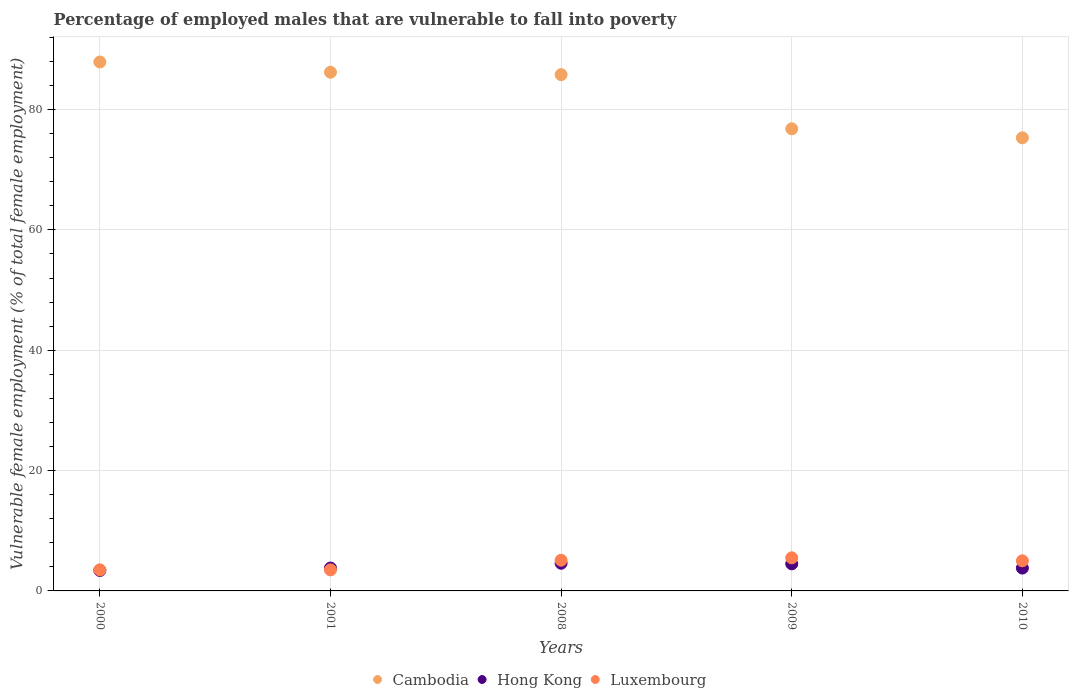How many different coloured dotlines are there?
Provide a short and direct response. 3. Across all years, what is the maximum percentage of employed males who are vulnerable to fall into poverty in Hong Kong?
Give a very brief answer. 4.6. Across all years, what is the minimum percentage of employed males who are vulnerable to fall into poverty in Hong Kong?
Your response must be concise. 3.4. What is the total percentage of employed males who are vulnerable to fall into poverty in Cambodia in the graph?
Your answer should be very brief. 412. What is the difference between the percentage of employed males who are vulnerable to fall into poverty in Luxembourg in 2008 and that in 2009?
Keep it short and to the point. -0.4. What is the difference between the percentage of employed males who are vulnerable to fall into poverty in Cambodia in 2009 and the percentage of employed males who are vulnerable to fall into poverty in Luxembourg in 2008?
Your answer should be very brief. 71.7. What is the average percentage of employed males who are vulnerable to fall into poverty in Hong Kong per year?
Provide a succinct answer. 4.02. In the year 2000, what is the difference between the percentage of employed males who are vulnerable to fall into poverty in Luxembourg and percentage of employed males who are vulnerable to fall into poverty in Cambodia?
Provide a succinct answer. -84.4. In how many years, is the percentage of employed males who are vulnerable to fall into poverty in Hong Kong greater than 12 %?
Ensure brevity in your answer.  0. What is the ratio of the percentage of employed males who are vulnerable to fall into poverty in Luxembourg in 2001 to that in 2010?
Ensure brevity in your answer.  0.7. Is the difference between the percentage of employed males who are vulnerable to fall into poverty in Luxembourg in 2000 and 2001 greater than the difference between the percentage of employed males who are vulnerable to fall into poverty in Cambodia in 2000 and 2001?
Ensure brevity in your answer.  No. What is the difference between the highest and the second highest percentage of employed males who are vulnerable to fall into poverty in Luxembourg?
Keep it short and to the point. 0.4. What is the difference between the highest and the lowest percentage of employed males who are vulnerable to fall into poverty in Cambodia?
Your answer should be very brief. 12.6. In how many years, is the percentage of employed males who are vulnerable to fall into poverty in Cambodia greater than the average percentage of employed males who are vulnerable to fall into poverty in Cambodia taken over all years?
Ensure brevity in your answer.  3. Is the percentage of employed males who are vulnerable to fall into poverty in Luxembourg strictly less than the percentage of employed males who are vulnerable to fall into poverty in Cambodia over the years?
Provide a succinct answer. Yes. How many dotlines are there?
Give a very brief answer. 3. Does the graph contain grids?
Provide a short and direct response. Yes. Where does the legend appear in the graph?
Offer a very short reply. Bottom center. What is the title of the graph?
Offer a very short reply. Percentage of employed males that are vulnerable to fall into poverty. Does "Micronesia" appear as one of the legend labels in the graph?
Make the answer very short. No. What is the label or title of the X-axis?
Your answer should be very brief. Years. What is the label or title of the Y-axis?
Provide a short and direct response. Vulnerable female employment (% of total female employment). What is the Vulnerable female employment (% of total female employment) in Cambodia in 2000?
Give a very brief answer. 87.9. What is the Vulnerable female employment (% of total female employment) in Hong Kong in 2000?
Your answer should be very brief. 3.4. What is the Vulnerable female employment (% of total female employment) of Cambodia in 2001?
Offer a very short reply. 86.2. What is the Vulnerable female employment (% of total female employment) of Hong Kong in 2001?
Offer a terse response. 3.8. What is the Vulnerable female employment (% of total female employment) in Luxembourg in 2001?
Make the answer very short. 3.5. What is the Vulnerable female employment (% of total female employment) in Cambodia in 2008?
Make the answer very short. 85.8. What is the Vulnerable female employment (% of total female employment) in Hong Kong in 2008?
Your answer should be compact. 4.6. What is the Vulnerable female employment (% of total female employment) in Luxembourg in 2008?
Provide a short and direct response. 5.1. What is the Vulnerable female employment (% of total female employment) of Cambodia in 2009?
Your answer should be very brief. 76.8. What is the Vulnerable female employment (% of total female employment) in Cambodia in 2010?
Offer a very short reply. 75.3. What is the Vulnerable female employment (% of total female employment) of Hong Kong in 2010?
Keep it short and to the point. 3.8. Across all years, what is the maximum Vulnerable female employment (% of total female employment) of Cambodia?
Your answer should be compact. 87.9. Across all years, what is the maximum Vulnerable female employment (% of total female employment) in Hong Kong?
Give a very brief answer. 4.6. Across all years, what is the maximum Vulnerable female employment (% of total female employment) of Luxembourg?
Your response must be concise. 5.5. Across all years, what is the minimum Vulnerable female employment (% of total female employment) in Cambodia?
Offer a terse response. 75.3. Across all years, what is the minimum Vulnerable female employment (% of total female employment) of Hong Kong?
Make the answer very short. 3.4. Across all years, what is the minimum Vulnerable female employment (% of total female employment) of Luxembourg?
Your answer should be very brief. 3.5. What is the total Vulnerable female employment (% of total female employment) in Cambodia in the graph?
Give a very brief answer. 412. What is the total Vulnerable female employment (% of total female employment) of Hong Kong in the graph?
Ensure brevity in your answer.  20.1. What is the total Vulnerable female employment (% of total female employment) in Luxembourg in the graph?
Offer a terse response. 22.6. What is the difference between the Vulnerable female employment (% of total female employment) in Luxembourg in 2000 and that in 2001?
Keep it short and to the point. 0. What is the difference between the Vulnerable female employment (% of total female employment) in Luxembourg in 2000 and that in 2008?
Your answer should be very brief. -1.6. What is the difference between the Vulnerable female employment (% of total female employment) of Hong Kong in 2000 and that in 2009?
Provide a short and direct response. -1.1. What is the difference between the Vulnerable female employment (% of total female employment) of Luxembourg in 2000 and that in 2010?
Make the answer very short. -1.5. What is the difference between the Vulnerable female employment (% of total female employment) of Hong Kong in 2001 and that in 2008?
Provide a short and direct response. -0.8. What is the difference between the Vulnerable female employment (% of total female employment) of Luxembourg in 2001 and that in 2008?
Ensure brevity in your answer.  -1.6. What is the difference between the Vulnerable female employment (% of total female employment) of Cambodia in 2001 and that in 2009?
Ensure brevity in your answer.  9.4. What is the difference between the Vulnerable female employment (% of total female employment) in Hong Kong in 2001 and that in 2009?
Your answer should be compact. -0.7. What is the difference between the Vulnerable female employment (% of total female employment) in Luxembourg in 2001 and that in 2009?
Keep it short and to the point. -2. What is the difference between the Vulnerable female employment (% of total female employment) in Hong Kong in 2001 and that in 2010?
Offer a terse response. 0. What is the difference between the Vulnerable female employment (% of total female employment) of Cambodia in 2008 and that in 2009?
Your answer should be compact. 9. What is the difference between the Vulnerable female employment (% of total female employment) of Luxembourg in 2008 and that in 2009?
Keep it short and to the point. -0.4. What is the difference between the Vulnerable female employment (% of total female employment) of Hong Kong in 2008 and that in 2010?
Offer a very short reply. 0.8. What is the difference between the Vulnerable female employment (% of total female employment) in Luxembourg in 2008 and that in 2010?
Your response must be concise. 0.1. What is the difference between the Vulnerable female employment (% of total female employment) of Cambodia in 2009 and that in 2010?
Your answer should be very brief. 1.5. What is the difference between the Vulnerable female employment (% of total female employment) in Hong Kong in 2009 and that in 2010?
Your response must be concise. 0.7. What is the difference between the Vulnerable female employment (% of total female employment) of Luxembourg in 2009 and that in 2010?
Provide a short and direct response. 0.5. What is the difference between the Vulnerable female employment (% of total female employment) in Cambodia in 2000 and the Vulnerable female employment (% of total female employment) in Hong Kong in 2001?
Provide a succinct answer. 84.1. What is the difference between the Vulnerable female employment (% of total female employment) in Cambodia in 2000 and the Vulnerable female employment (% of total female employment) in Luxembourg in 2001?
Give a very brief answer. 84.4. What is the difference between the Vulnerable female employment (% of total female employment) in Hong Kong in 2000 and the Vulnerable female employment (% of total female employment) in Luxembourg in 2001?
Your response must be concise. -0.1. What is the difference between the Vulnerable female employment (% of total female employment) of Cambodia in 2000 and the Vulnerable female employment (% of total female employment) of Hong Kong in 2008?
Make the answer very short. 83.3. What is the difference between the Vulnerable female employment (% of total female employment) in Cambodia in 2000 and the Vulnerable female employment (% of total female employment) in Luxembourg in 2008?
Your response must be concise. 82.8. What is the difference between the Vulnerable female employment (% of total female employment) in Hong Kong in 2000 and the Vulnerable female employment (% of total female employment) in Luxembourg in 2008?
Ensure brevity in your answer.  -1.7. What is the difference between the Vulnerable female employment (% of total female employment) of Cambodia in 2000 and the Vulnerable female employment (% of total female employment) of Hong Kong in 2009?
Provide a short and direct response. 83.4. What is the difference between the Vulnerable female employment (% of total female employment) of Cambodia in 2000 and the Vulnerable female employment (% of total female employment) of Luxembourg in 2009?
Offer a very short reply. 82.4. What is the difference between the Vulnerable female employment (% of total female employment) in Cambodia in 2000 and the Vulnerable female employment (% of total female employment) in Hong Kong in 2010?
Offer a terse response. 84.1. What is the difference between the Vulnerable female employment (% of total female employment) of Cambodia in 2000 and the Vulnerable female employment (% of total female employment) of Luxembourg in 2010?
Offer a terse response. 82.9. What is the difference between the Vulnerable female employment (% of total female employment) of Hong Kong in 2000 and the Vulnerable female employment (% of total female employment) of Luxembourg in 2010?
Your answer should be compact. -1.6. What is the difference between the Vulnerable female employment (% of total female employment) of Cambodia in 2001 and the Vulnerable female employment (% of total female employment) of Hong Kong in 2008?
Ensure brevity in your answer.  81.6. What is the difference between the Vulnerable female employment (% of total female employment) in Cambodia in 2001 and the Vulnerable female employment (% of total female employment) in Luxembourg in 2008?
Offer a terse response. 81.1. What is the difference between the Vulnerable female employment (% of total female employment) in Hong Kong in 2001 and the Vulnerable female employment (% of total female employment) in Luxembourg in 2008?
Offer a very short reply. -1.3. What is the difference between the Vulnerable female employment (% of total female employment) in Cambodia in 2001 and the Vulnerable female employment (% of total female employment) in Hong Kong in 2009?
Your answer should be compact. 81.7. What is the difference between the Vulnerable female employment (% of total female employment) of Cambodia in 2001 and the Vulnerable female employment (% of total female employment) of Luxembourg in 2009?
Your response must be concise. 80.7. What is the difference between the Vulnerable female employment (% of total female employment) in Hong Kong in 2001 and the Vulnerable female employment (% of total female employment) in Luxembourg in 2009?
Offer a very short reply. -1.7. What is the difference between the Vulnerable female employment (% of total female employment) of Cambodia in 2001 and the Vulnerable female employment (% of total female employment) of Hong Kong in 2010?
Keep it short and to the point. 82.4. What is the difference between the Vulnerable female employment (% of total female employment) of Cambodia in 2001 and the Vulnerable female employment (% of total female employment) of Luxembourg in 2010?
Provide a succinct answer. 81.2. What is the difference between the Vulnerable female employment (% of total female employment) in Hong Kong in 2001 and the Vulnerable female employment (% of total female employment) in Luxembourg in 2010?
Provide a succinct answer. -1.2. What is the difference between the Vulnerable female employment (% of total female employment) in Cambodia in 2008 and the Vulnerable female employment (% of total female employment) in Hong Kong in 2009?
Offer a very short reply. 81.3. What is the difference between the Vulnerable female employment (% of total female employment) in Cambodia in 2008 and the Vulnerable female employment (% of total female employment) in Luxembourg in 2009?
Ensure brevity in your answer.  80.3. What is the difference between the Vulnerable female employment (% of total female employment) in Hong Kong in 2008 and the Vulnerable female employment (% of total female employment) in Luxembourg in 2009?
Your response must be concise. -0.9. What is the difference between the Vulnerable female employment (% of total female employment) of Cambodia in 2008 and the Vulnerable female employment (% of total female employment) of Hong Kong in 2010?
Ensure brevity in your answer.  82. What is the difference between the Vulnerable female employment (% of total female employment) in Cambodia in 2008 and the Vulnerable female employment (% of total female employment) in Luxembourg in 2010?
Your answer should be compact. 80.8. What is the difference between the Vulnerable female employment (% of total female employment) in Cambodia in 2009 and the Vulnerable female employment (% of total female employment) in Hong Kong in 2010?
Ensure brevity in your answer.  73. What is the difference between the Vulnerable female employment (% of total female employment) of Cambodia in 2009 and the Vulnerable female employment (% of total female employment) of Luxembourg in 2010?
Keep it short and to the point. 71.8. What is the average Vulnerable female employment (% of total female employment) of Cambodia per year?
Provide a succinct answer. 82.4. What is the average Vulnerable female employment (% of total female employment) of Hong Kong per year?
Offer a very short reply. 4.02. What is the average Vulnerable female employment (% of total female employment) of Luxembourg per year?
Offer a very short reply. 4.52. In the year 2000, what is the difference between the Vulnerable female employment (% of total female employment) of Cambodia and Vulnerable female employment (% of total female employment) of Hong Kong?
Your response must be concise. 84.5. In the year 2000, what is the difference between the Vulnerable female employment (% of total female employment) in Cambodia and Vulnerable female employment (% of total female employment) in Luxembourg?
Your answer should be compact. 84.4. In the year 2001, what is the difference between the Vulnerable female employment (% of total female employment) of Cambodia and Vulnerable female employment (% of total female employment) of Hong Kong?
Ensure brevity in your answer.  82.4. In the year 2001, what is the difference between the Vulnerable female employment (% of total female employment) in Cambodia and Vulnerable female employment (% of total female employment) in Luxembourg?
Your answer should be compact. 82.7. In the year 2008, what is the difference between the Vulnerable female employment (% of total female employment) of Cambodia and Vulnerable female employment (% of total female employment) of Hong Kong?
Offer a very short reply. 81.2. In the year 2008, what is the difference between the Vulnerable female employment (% of total female employment) in Cambodia and Vulnerable female employment (% of total female employment) in Luxembourg?
Keep it short and to the point. 80.7. In the year 2008, what is the difference between the Vulnerable female employment (% of total female employment) in Hong Kong and Vulnerable female employment (% of total female employment) in Luxembourg?
Provide a short and direct response. -0.5. In the year 2009, what is the difference between the Vulnerable female employment (% of total female employment) in Cambodia and Vulnerable female employment (% of total female employment) in Hong Kong?
Your answer should be very brief. 72.3. In the year 2009, what is the difference between the Vulnerable female employment (% of total female employment) in Cambodia and Vulnerable female employment (% of total female employment) in Luxembourg?
Your answer should be very brief. 71.3. In the year 2009, what is the difference between the Vulnerable female employment (% of total female employment) in Hong Kong and Vulnerable female employment (% of total female employment) in Luxembourg?
Your answer should be very brief. -1. In the year 2010, what is the difference between the Vulnerable female employment (% of total female employment) in Cambodia and Vulnerable female employment (% of total female employment) in Hong Kong?
Your answer should be very brief. 71.5. In the year 2010, what is the difference between the Vulnerable female employment (% of total female employment) in Cambodia and Vulnerable female employment (% of total female employment) in Luxembourg?
Offer a very short reply. 70.3. What is the ratio of the Vulnerable female employment (% of total female employment) of Cambodia in 2000 to that in 2001?
Provide a short and direct response. 1.02. What is the ratio of the Vulnerable female employment (% of total female employment) in Hong Kong in 2000 to that in 2001?
Provide a short and direct response. 0.89. What is the ratio of the Vulnerable female employment (% of total female employment) in Luxembourg in 2000 to that in 2001?
Provide a succinct answer. 1. What is the ratio of the Vulnerable female employment (% of total female employment) of Cambodia in 2000 to that in 2008?
Your answer should be compact. 1.02. What is the ratio of the Vulnerable female employment (% of total female employment) in Hong Kong in 2000 to that in 2008?
Keep it short and to the point. 0.74. What is the ratio of the Vulnerable female employment (% of total female employment) in Luxembourg in 2000 to that in 2008?
Your answer should be compact. 0.69. What is the ratio of the Vulnerable female employment (% of total female employment) of Cambodia in 2000 to that in 2009?
Your answer should be very brief. 1.14. What is the ratio of the Vulnerable female employment (% of total female employment) of Hong Kong in 2000 to that in 2009?
Provide a short and direct response. 0.76. What is the ratio of the Vulnerable female employment (% of total female employment) of Luxembourg in 2000 to that in 2009?
Offer a very short reply. 0.64. What is the ratio of the Vulnerable female employment (% of total female employment) in Cambodia in 2000 to that in 2010?
Your answer should be very brief. 1.17. What is the ratio of the Vulnerable female employment (% of total female employment) of Hong Kong in 2000 to that in 2010?
Offer a terse response. 0.89. What is the ratio of the Vulnerable female employment (% of total female employment) in Hong Kong in 2001 to that in 2008?
Your answer should be compact. 0.83. What is the ratio of the Vulnerable female employment (% of total female employment) of Luxembourg in 2001 to that in 2008?
Provide a short and direct response. 0.69. What is the ratio of the Vulnerable female employment (% of total female employment) in Cambodia in 2001 to that in 2009?
Offer a terse response. 1.12. What is the ratio of the Vulnerable female employment (% of total female employment) of Hong Kong in 2001 to that in 2009?
Keep it short and to the point. 0.84. What is the ratio of the Vulnerable female employment (% of total female employment) of Luxembourg in 2001 to that in 2009?
Offer a very short reply. 0.64. What is the ratio of the Vulnerable female employment (% of total female employment) in Cambodia in 2001 to that in 2010?
Your answer should be compact. 1.14. What is the ratio of the Vulnerable female employment (% of total female employment) of Hong Kong in 2001 to that in 2010?
Your answer should be very brief. 1. What is the ratio of the Vulnerable female employment (% of total female employment) in Luxembourg in 2001 to that in 2010?
Your answer should be very brief. 0.7. What is the ratio of the Vulnerable female employment (% of total female employment) in Cambodia in 2008 to that in 2009?
Provide a succinct answer. 1.12. What is the ratio of the Vulnerable female employment (% of total female employment) of Hong Kong in 2008 to that in 2009?
Keep it short and to the point. 1.02. What is the ratio of the Vulnerable female employment (% of total female employment) in Luxembourg in 2008 to that in 2009?
Your response must be concise. 0.93. What is the ratio of the Vulnerable female employment (% of total female employment) of Cambodia in 2008 to that in 2010?
Provide a succinct answer. 1.14. What is the ratio of the Vulnerable female employment (% of total female employment) in Hong Kong in 2008 to that in 2010?
Your answer should be compact. 1.21. What is the ratio of the Vulnerable female employment (% of total female employment) in Cambodia in 2009 to that in 2010?
Your answer should be compact. 1.02. What is the ratio of the Vulnerable female employment (% of total female employment) in Hong Kong in 2009 to that in 2010?
Your answer should be very brief. 1.18. What is the ratio of the Vulnerable female employment (% of total female employment) in Luxembourg in 2009 to that in 2010?
Make the answer very short. 1.1. What is the difference between the highest and the second highest Vulnerable female employment (% of total female employment) in Cambodia?
Your response must be concise. 1.7. What is the difference between the highest and the lowest Vulnerable female employment (% of total female employment) of Cambodia?
Your answer should be compact. 12.6. What is the difference between the highest and the lowest Vulnerable female employment (% of total female employment) of Luxembourg?
Give a very brief answer. 2. 